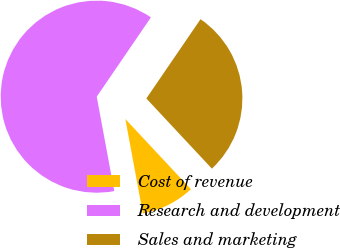Convert chart to OTSL. <chart><loc_0><loc_0><loc_500><loc_500><pie_chart><fcel>Cost of revenue<fcel>Research and development<fcel>Sales and marketing<nl><fcel>9.04%<fcel>62.46%<fcel>28.5%<nl></chart> 